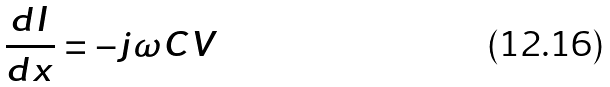<formula> <loc_0><loc_0><loc_500><loc_500>\frac { d I } { d x } = - j \omega C V</formula> 